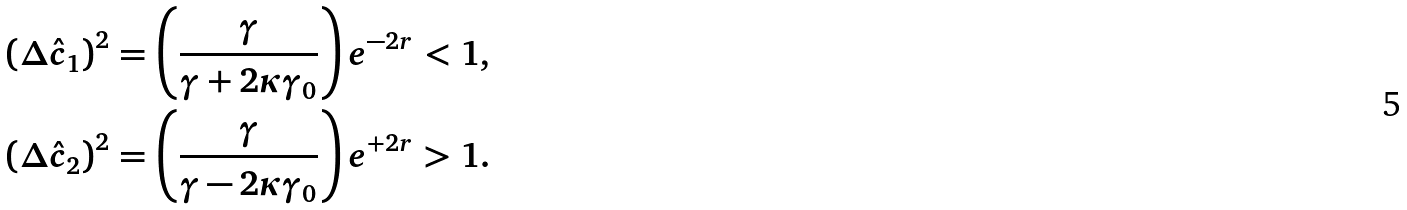Convert formula to latex. <formula><loc_0><loc_0><loc_500><loc_500>& \left ( \Delta \hat { c } _ { 1 } \right ) ^ { 2 } = \left ( \frac { \gamma } { \gamma + 2 \kappa \gamma _ { 0 } } \right ) e ^ { - 2 r } < 1 , \\ & \left ( \Delta \hat { c } _ { 2 } \right ) ^ { 2 } = \left ( \frac { \gamma } { \gamma - 2 \kappa \gamma _ { 0 } } \right ) e ^ { + 2 r } > 1 .</formula> 